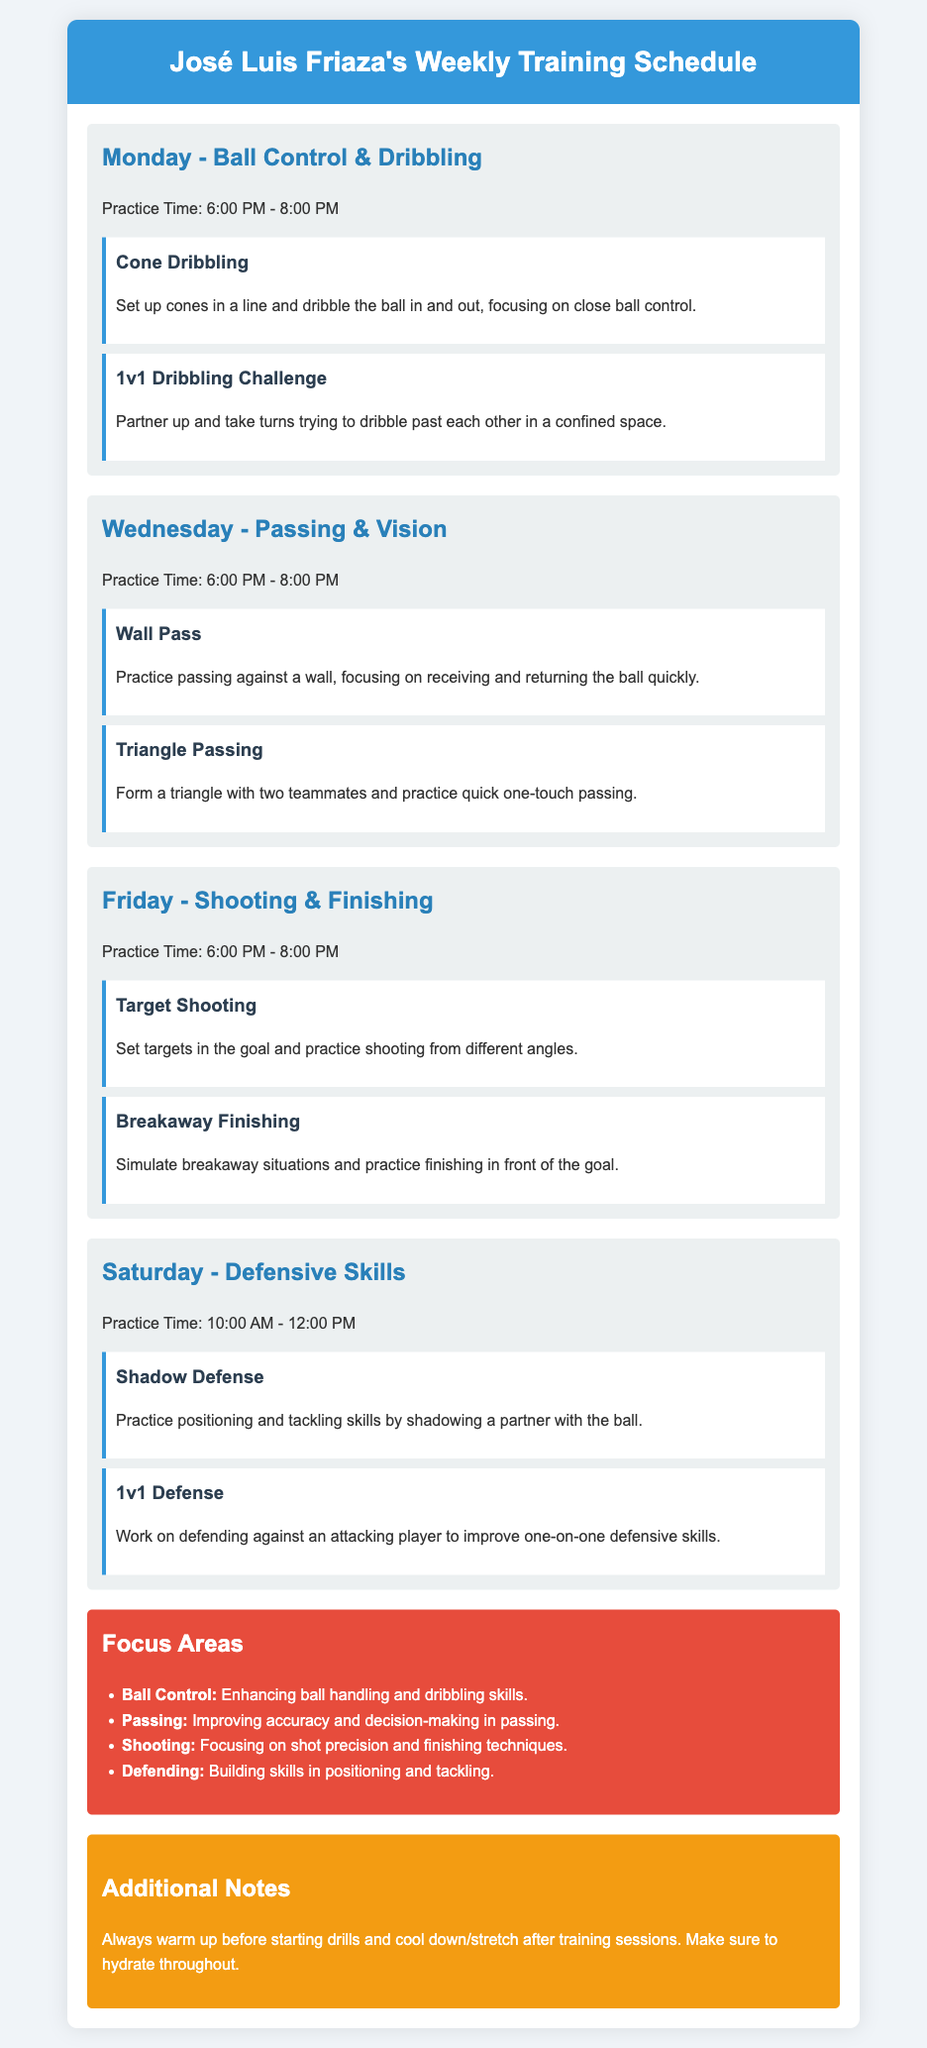What day is focused on ball control and dribbling? The document specifies Monday as the day focused on ball control and dribbling.
Answer: Monday What time does the shooting and finishing practice start? The document indicates that shooting and finishing practice starts at 6:00 PM.
Answer: 6:00 PM What type of drill involves practicing passing against a wall? The document mentions the "Wall Pass" as the drill for practicing passing against a wall.
Answer: Wall Pass How many drills are listed for the Saturday practice? There are two drills listed for Saturday's practice in the document.
Answer: Two Which skill area focuses on building skills in positioning and tackling? The document states that "Defending" is the skill area focused on positioning and tackling.
Answer: Defending What is the purpose of the "1v1 Dribbling Challenge"? The document explains that this challenge is to take turns dribbling past each other in a confined space.
Answer: Dribbling past each other What should be done before starting drills according to the additional notes? The additional notes recommend warming up before starting drills.
Answer: Warm up What is the practice time for defensive skills on Saturday? The document specifies that defensive skills practice is from 10:00 AM to 12:00 PM.
Answer: 10:00 AM - 12:00 PM What are the main focus areas listed in the document? The document lists ball control, passing, shooting, and defending as the main focus areas.
Answer: Ball control, passing, shooting, defending 